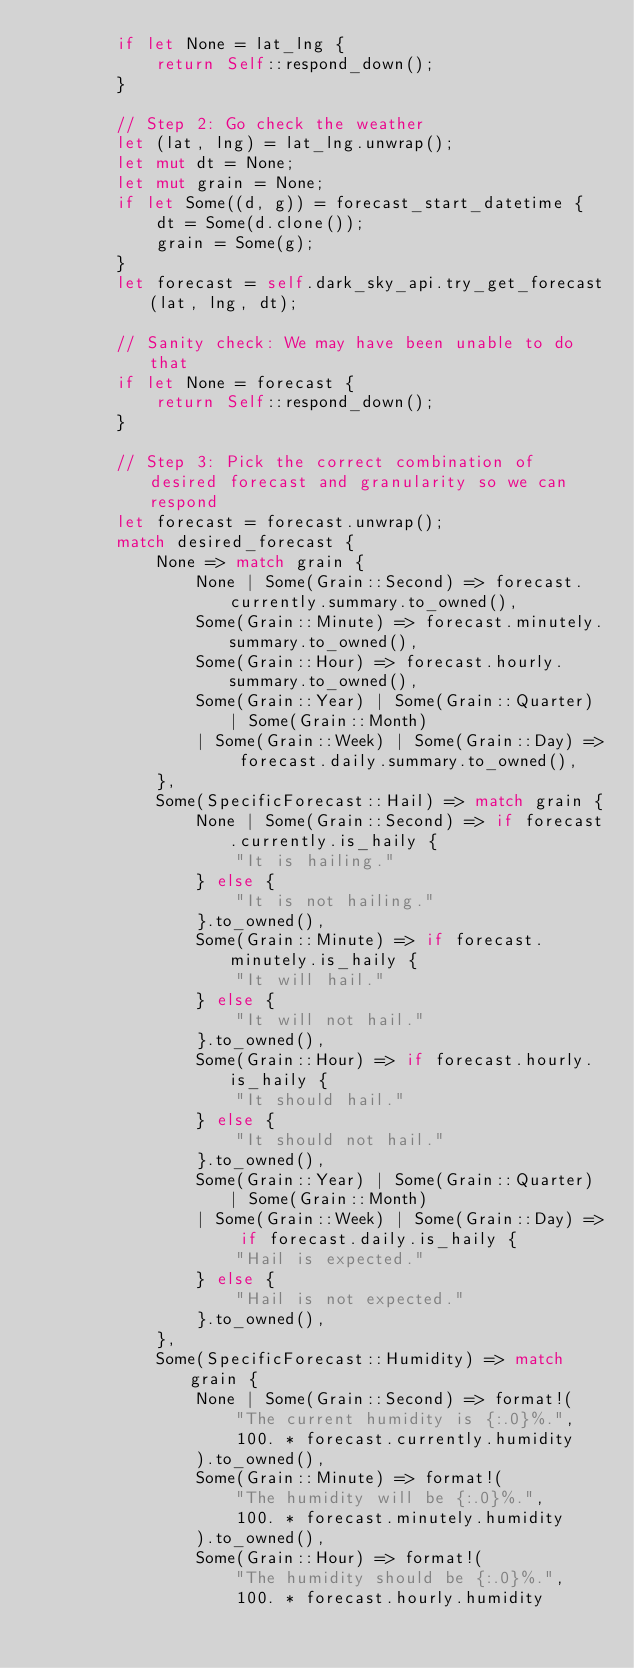<code> <loc_0><loc_0><loc_500><loc_500><_Rust_>        if let None = lat_lng {
            return Self::respond_down();
        }

        // Step 2: Go check the weather
        let (lat, lng) = lat_lng.unwrap();
        let mut dt = None;
        let mut grain = None;
        if let Some((d, g)) = forecast_start_datetime {
            dt = Some(d.clone());
            grain = Some(g);
        }
        let forecast = self.dark_sky_api.try_get_forecast(lat, lng, dt);

        // Sanity check: We may have been unable to do that
        if let None = forecast {
            return Self::respond_down();
        }

        // Step 3: Pick the correct combination of desired forecast and granularity so we can respond
        let forecast = forecast.unwrap();
        match desired_forecast {
            None => match grain {
                None | Some(Grain::Second) => forecast.currently.summary.to_owned(),
                Some(Grain::Minute) => forecast.minutely.summary.to_owned(),
                Some(Grain::Hour) => forecast.hourly.summary.to_owned(),
                Some(Grain::Year) | Some(Grain::Quarter) | Some(Grain::Month)
                | Some(Grain::Week) | Some(Grain::Day) => forecast.daily.summary.to_owned(),
            },
            Some(SpecificForecast::Hail) => match grain {
                None | Some(Grain::Second) => if forecast.currently.is_haily {
                    "It is hailing."
                } else {
                    "It is not hailing."
                }.to_owned(),
                Some(Grain::Minute) => if forecast.minutely.is_haily {
                    "It will hail."
                } else {
                    "It will not hail."
                }.to_owned(),
                Some(Grain::Hour) => if forecast.hourly.is_haily {
                    "It should hail."
                } else {
                    "It should not hail."
                }.to_owned(),
                Some(Grain::Year) | Some(Grain::Quarter) | Some(Grain::Month)
                | Some(Grain::Week) | Some(Grain::Day) => if forecast.daily.is_haily {
                    "Hail is expected."
                } else {
                    "Hail is not expected."
                }.to_owned(),
            },
            Some(SpecificForecast::Humidity) => match grain {
                None | Some(Grain::Second) => format!(
                    "The current humidity is {:.0}%.",
                    100. * forecast.currently.humidity
                ).to_owned(),
                Some(Grain::Minute) => format!(
                    "The humidity will be {:.0}%.",
                    100. * forecast.minutely.humidity
                ).to_owned(),
                Some(Grain::Hour) => format!(
                    "The humidity should be {:.0}%.",
                    100. * forecast.hourly.humidity</code> 